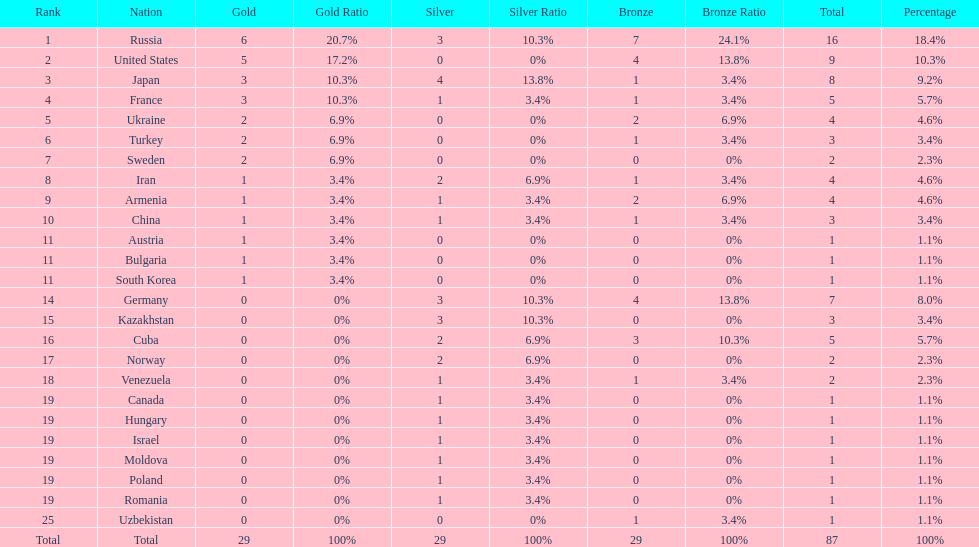Who ranked right after turkey? Sweden. Parse the full table. {'header': ['Rank', 'Nation', 'Gold', 'Gold Ratio', 'Silver', 'Silver Ratio', 'Bronze', 'Bronze Ratio', 'Total', 'Percentage'], 'rows': [['1', 'Russia', '6', '20.7%', '3', '10.3%', '7', '24.1%', '16', '18.4%'], ['2', 'United States', '5', '17.2%', '0', '0%', '4', '13.8%', '9', '10.3%'], ['3', 'Japan', '3', '10.3%', '4', '13.8%', '1', '3.4%', '8', '9.2%'], ['4', 'France', '3', '10.3%', '1', '3.4%', '1', '3.4%', '5', '5.7%'], ['5', 'Ukraine', '2', '6.9%', '0', '0%', '2', '6.9%', '4', '4.6%'], ['6', 'Turkey', '2', '6.9%', '0', '0%', '1', '3.4%', '3', '3.4%'], ['7', 'Sweden', '2', '6.9%', '0', '0%', '0', '0%', '2', '2.3%'], ['8', 'Iran', '1', '3.4%', '2', '6.9%', '1', '3.4%', '4', '4.6%'], ['9', 'Armenia', '1', '3.4%', '1', '3.4%', '2', '6.9%', '4', '4.6%'], ['10', 'China', '1', '3.4%', '1', '3.4%', '1', '3.4%', '3', '3.4%'], ['11', 'Austria', '1', '3.4%', '0', '0%', '0', '0%', '1', '1.1%'], ['11', 'Bulgaria', '1', '3.4%', '0', '0%', '0', '0%', '1', '1.1%'], ['11', 'South Korea', '1', '3.4%', '0', '0%', '0', '0%', '1', '1.1%'], ['14', 'Germany', '0', '0%', '3', '10.3%', '4', '13.8%', '7', '8.0%'], ['15', 'Kazakhstan', '0', '0%', '3', '10.3%', '0', '0%', '3', '3.4%'], ['16', 'Cuba', '0', '0%', '2', '6.9%', '3', '10.3%', '5', '5.7%'], ['17', 'Norway', '0', '0%', '2', '6.9%', '0', '0%', '2', '2.3%'], ['18', 'Venezuela', '0', '0%', '1', '3.4%', '1', '3.4%', '2', '2.3%'], ['19', 'Canada', '0', '0%', '1', '3.4%', '0', '0%', '1', '1.1%'], ['19', 'Hungary', '0', '0%', '1', '3.4%', '0', '0%', '1', '1.1%'], ['19', 'Israel', '0', '0%', '1', '3.4%', '0', '0%', '1', '1.1%'], ['19', 'Moldova', '0', '0%', '1', '3.4%', '0', '0%', '1', '1.1%'], ['19', 'Poland', '0', '0%', '1', '3.4%', '0', '0%', '1', '1.1%'], ['19', 'Romania', '0', '0%', '1', '3.4%', '0', '0%', '1', '1.1%'], ['25', 'Uzbekistan', '0', '0%', '0', '0%', '1', '3.4%', '1', '1.1%'], ['Total', 'Total', '29', '100%', '29', '100%', '29', '100%', '87', '100%']]} 